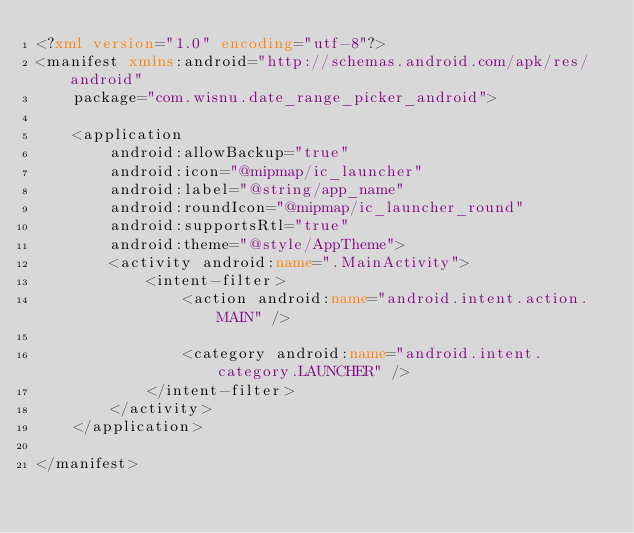<code> <loc_0><loc_0><loc_500><loc_500><_XML_><?xml version="1.0" encoding="utf-8"?>
<manifest xmlns:android="http://schemas.android.com/apk/res/android"
    package="com.wisnu.date_range_picker_android">

    <application
        android:allowBackup="true"
        android:icon="@mipmap/ic_launcher"
        android:label="@string/app_name"
        android:roundIcon="@mipmap/ic_launcher_round"
        android:supportsRtl="true"
        android:theme="@style/AppTheme">
        <activity android:name=".MainActivity">
            <intent-filter>
                <action android:name="android.intent.action.MAIN" />

                <category android:name="android.intent.category.LAUNCHER" />
            </intent-filter>
        </activity>
    </application>

</manifest></code> 